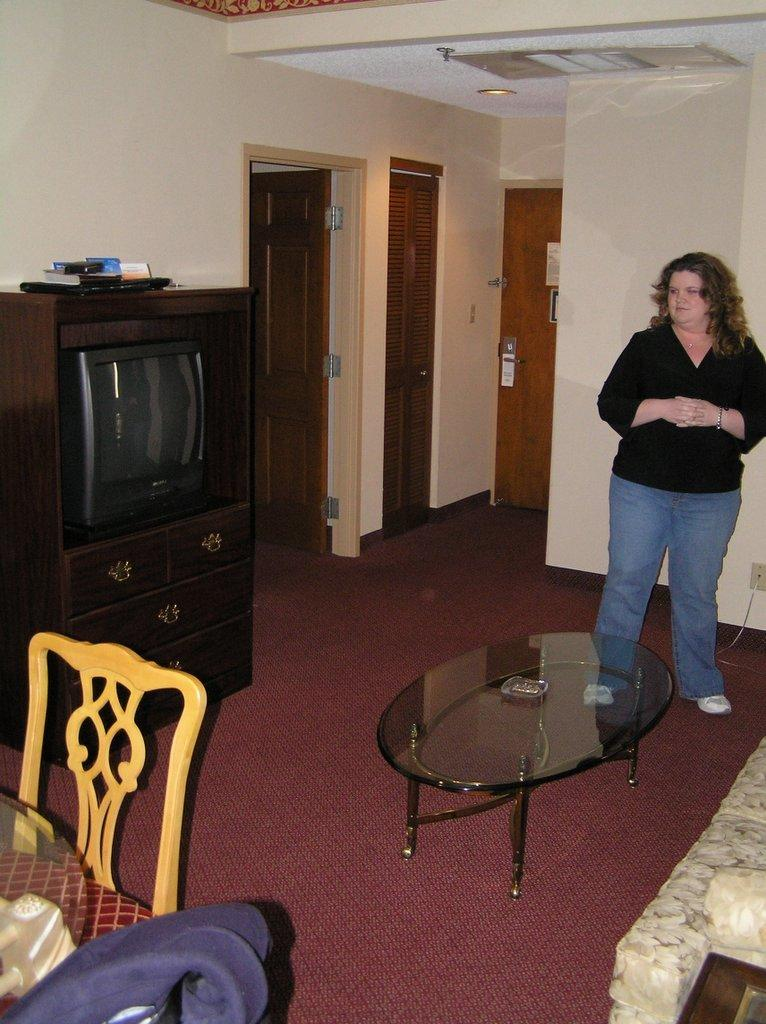What is the main subject in the image? There is a woman standing in the image. What furniture can be seen in the image? There is a table, a bed, a sofa, a cupboard, and a chair in the image. Are there any architectural features in the image? Yes, there are doors in the image. What type of waves can be seen crashing against the shore in the image? There is no reference to a shore or waves in the image; it features a woman standing with various pieces of furniture and architectural features. 